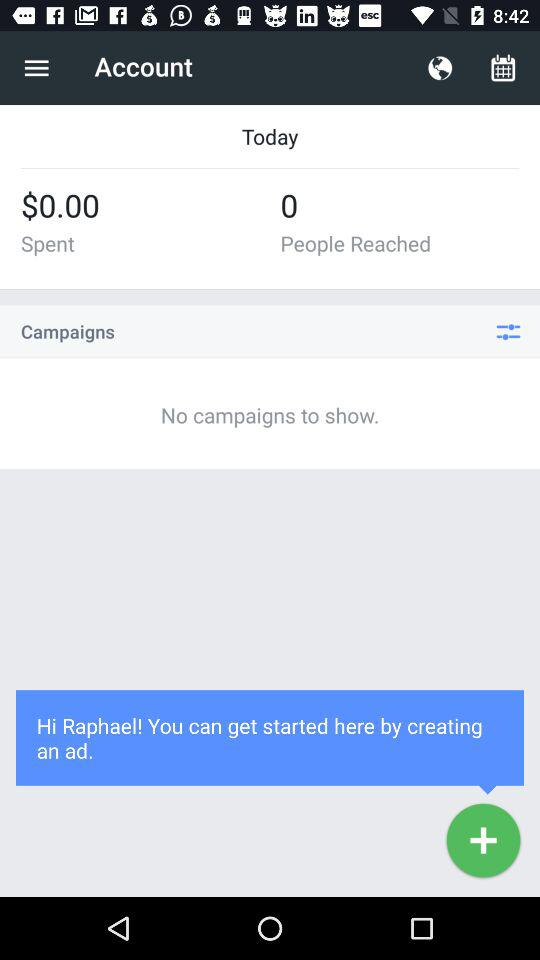How many campaigns are there?
Answer the question using a single word or phrase. 0 